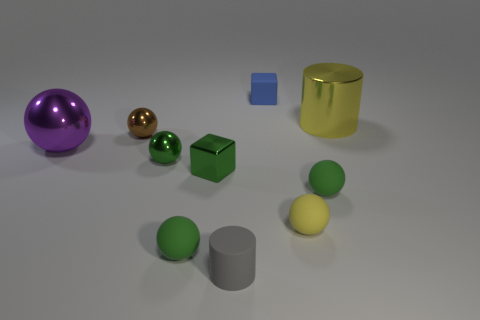What is the tiny thing that is both behind the purple ball and on the right side of the brown shiny ball made of?
Provide a short and direct response. Rubber. Does the cylinder that is in front of the brown ball have the same color as the big thing that is behind the purple sphere?
Your response must be concise. No. How many blue objects are either rubber blocks or rubber cylinders?
Your answer should be very brief. 1. Are there fewer tiny gray objects right of the tiny yellow matte ball than objects behind the large purple metal ball?
Keep it short and to the point. Yes. Are there any gray things of the same size as the matte cylinder?
Offer a very short reply. No. Is the size of the cube in front of the brown sphere the same as the small cylinder?
Provide a short and direct response. Yes. Are there more large gray matte things than rubber cylinders?
Your response must be concise. No. Are there any small brown objects of the same shape as the gray rubber object?
Provide a short and direct response. No. The object on the left side of the tiny brown metal ball has what shape?
Offer a very short reply. Sphere. What number of green metallic things are to the left of the small cube that is behind the small block in front of the blue object?
Offer a terse response. 2. 